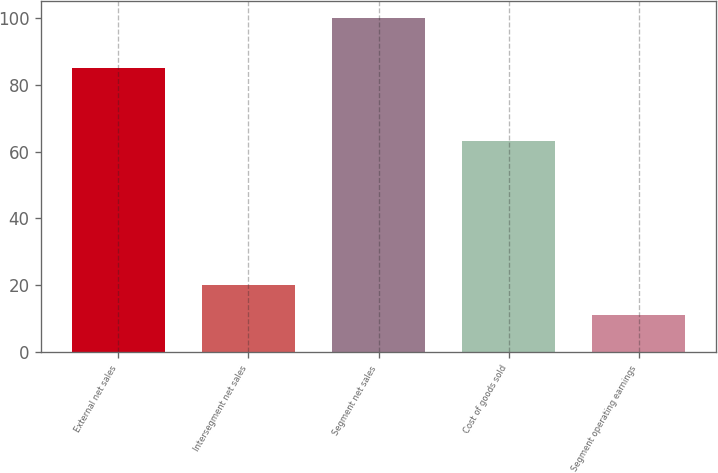<chart> <loc_0><loc_0><loc_500><loc_500><bar_chart><fcel>External net sales<fcel>Intersegment net sales<fcel>Segment net sales<fcel>Cost of goods sold<fcel>Segment operating earnings<nl><fcel>85<fcel>20.08<fcel>100<fcel>63.2<fcel>11.2<nl></chart> 